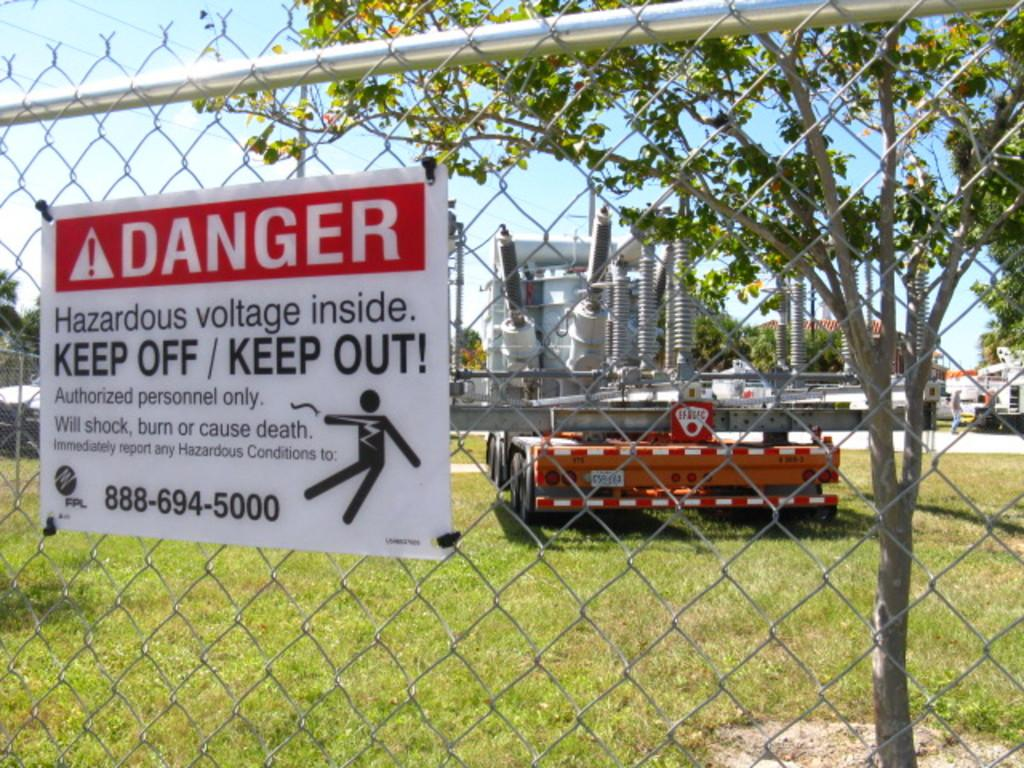What is present in the image that separates different areas? There is a fence in the image. What is attached to the fence? There is a notice paper attached to the fence. What can be seen beyond the fence? Vehicles, the sky, trees, and a person are visible through the fence. What type of scarf is the person wearing in the image? There is no person wearing a scarf in the image; the person visible through the fence is not wearing a scarf. What is the texture of the flesh visible through the fence? There is no flesh visible through the fence; the image only shows a person, vehicles, the sky, and trees beyond the fence. 